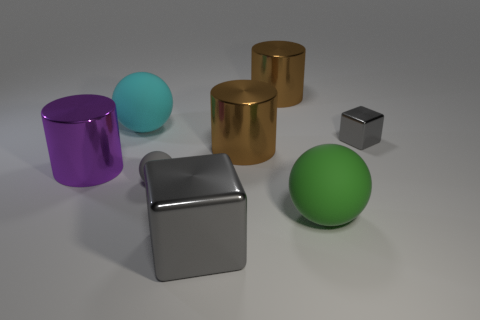There is a gray object on the left side of the block in front of the gray metal thing that is behind the large gray shiny object; what shape is it?
Your response must be concise. Sphere. There is another tiny thing that is the same color as the small rubber thing; what is its material?
Your answer should be very brief. Metal. What number of other objects are the same shape as the small shiny object?
Keep it short and to the point. 1. Do the shiny object to the left of the small gray matte object and the metal cube that is behind the big gray block have the same color?
Give a very brief answer. No. There is a green ball that is the same size as the cyan ball; what material is it?
Give a very brief answer. Rubber. Is there a blue matte sphere of the same size as the cyan rubber sphere?
Provide a succinct answer. No. Are there fewer large brown cylinders that are in front of the small gray cube than big blue blocks?
Offer a terse response. No. Are there fewer large cubes in front of the tiny gray block than brown things that are in front of the small gray rubber sphere?
Keep it short and to the point. No. How many cylinders are either big shiny objects or purple objects?
Provide a succinct answer. 3. Does the large brown thing behind the cyan rubber sphere have the same material as the ball behind the gray matte object?
Provide a short and direct response. No. 